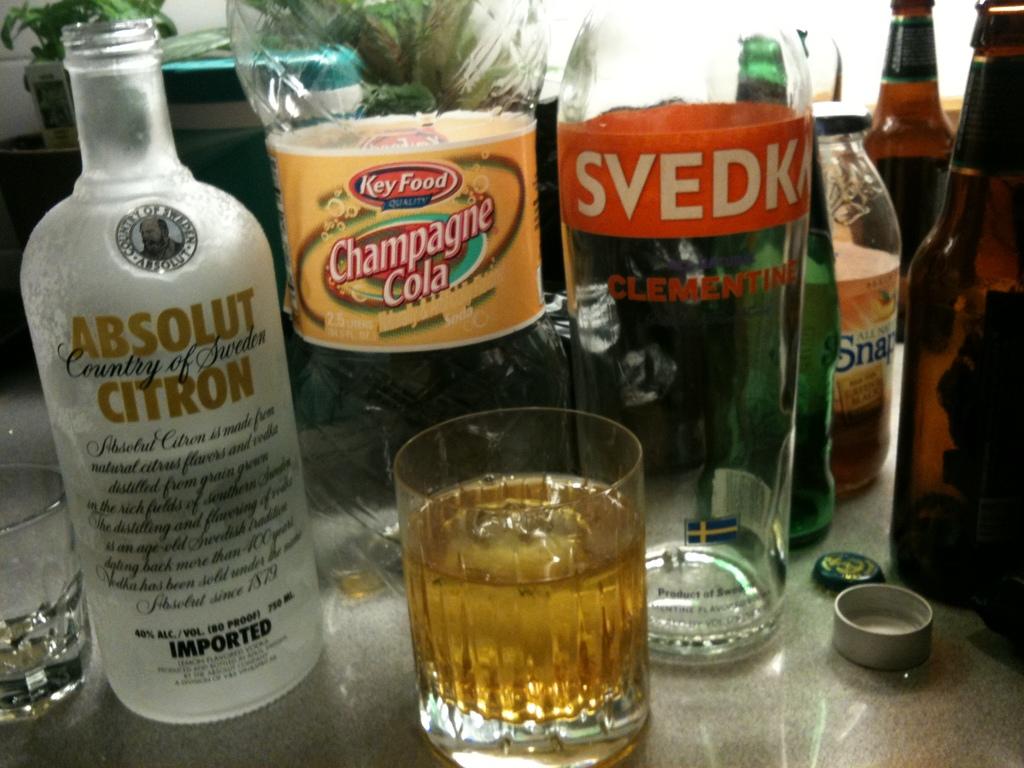What kind of cola is shown?
Your answer should be very brief. Champagne. 